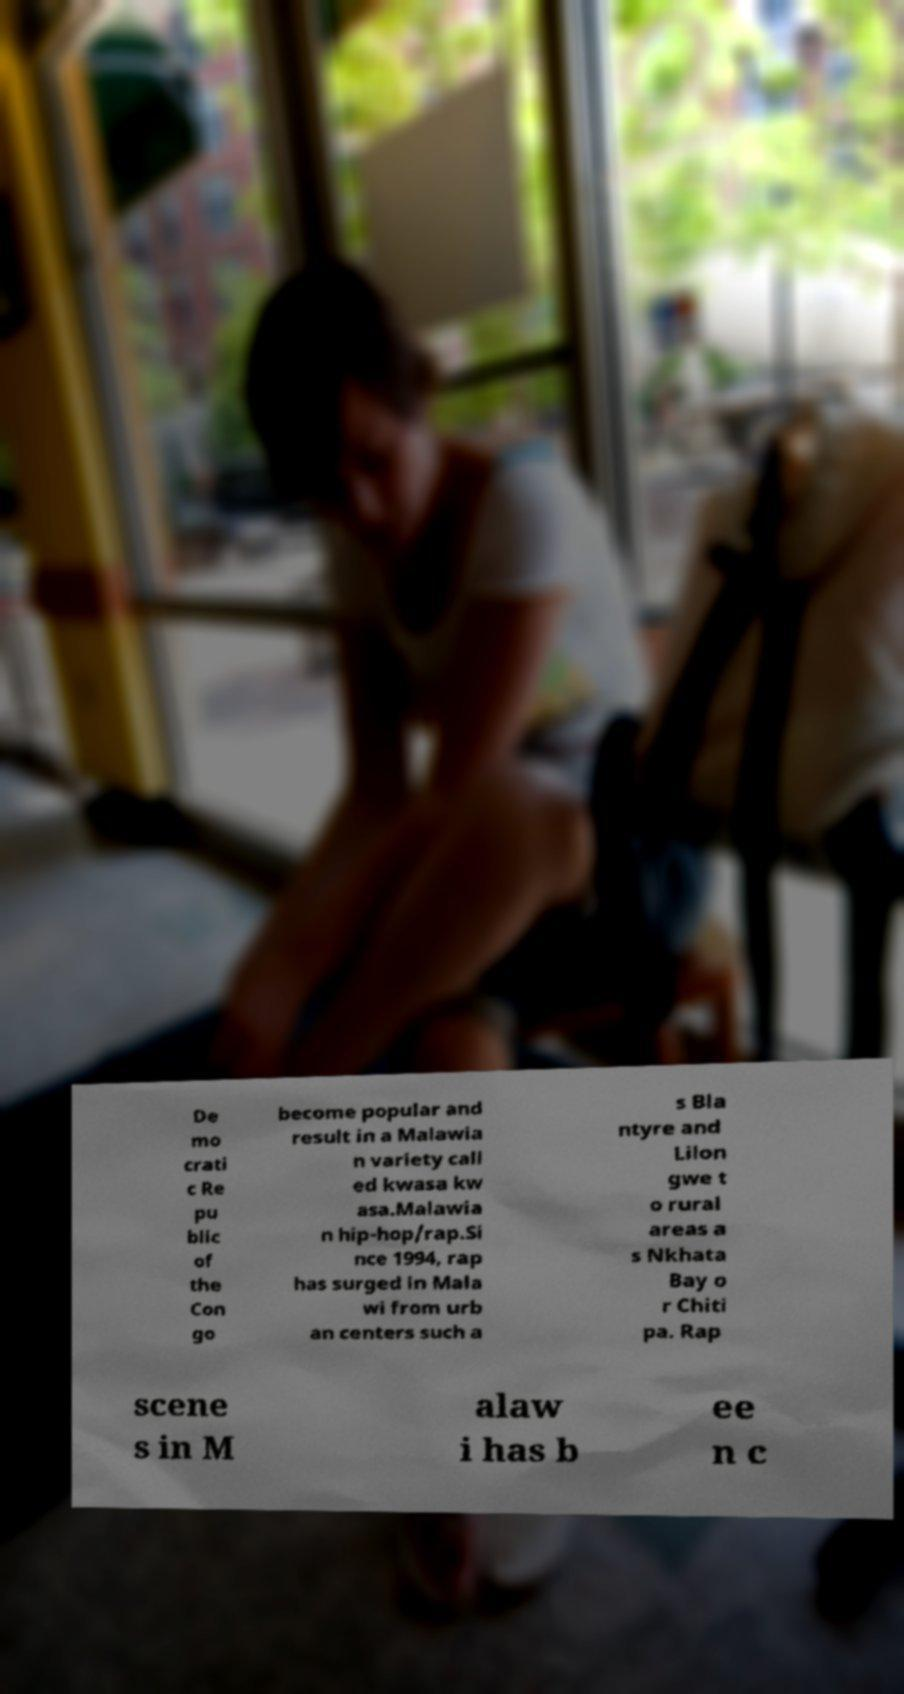Could you extract and type out the text from this image? De mo crati c Re pu blic of the Con go become popular and result in a Malawia n variety call ed kwasa kw asa.Malawia n hip-hop/rap.Si nce 1994, rap has surged in Mala wi from urb an centers such a s Bla ntyre and Lilon gwe t o rural areas a s Nkhata Bay o r Chiti pa. Rap scene s in M alaw i has b ee n c 